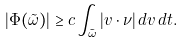Convert formula to latex. <formula><loc_0><loc_0><loc_500><loc_500>| \Phi ( \tilde { \omega } ) | \geq c \int _ { \tilde { \omega } } | v \cdot \nu | \, d v \, d t .</formula> 